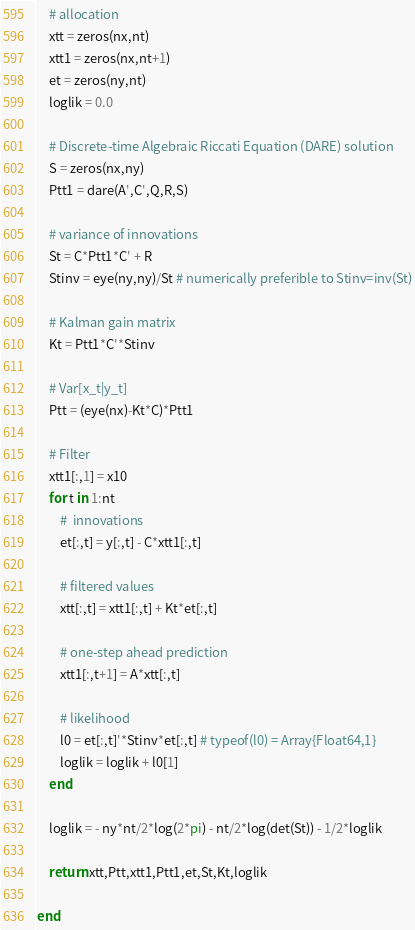<code> <loc_0><loc_0><loc_500><loc_500><_Julia_>	# allocation
	xtt = zeros(nx,nt)
	xtt1 = zeros(nx,nt+1)
	et = zeros(ny,nt)
	loglik = 0.0

	# Discrete-time Algebraic Riccati Equation (DARE) solution
	S = zeros(nx,ny)
	Ptt1 = dare(A',C',Q,R,S)

	# variance of innovations
	St = C*Ptt1*C' + R 
	Stinv = eye(ny,ny)/St # numerically preferible to Stinv=inv(St)
	
	# Kalman gain matrix
	Kt = Ptt1*C'*Stinv
	
	# Var[x_t|y_t]
	Ptt = (eye(nx)-Kt*C)*Ptt1

	# Filter
	xtt1[:,1] = x10
	for t in 1:nt
		#  innovations
		et[:,t] = y[:,t] - C*xtt1[:,t] 
	
		# filtered values
		xtt[:,t] = xtt1[:,t] + Kt*et[:,t]
		
		# one-step ahead prediction
		xtt1[:,t+1] = A*xtt[:,t]
		
		# likelihood
		l0 = et[:,t]'*Stinv*et[:,t] # typeof(l0) = Array{Float64,1}
		loglik = loglik + l0[1]	
	end
	
	loglik = - ny*nt/2*log(2*pi) - nt/2*log(det(St)) - 1/2*loglik

	return xtt,Ptt,xtt1,Ptt1,et,St,Kt,loglik

end

</code> 